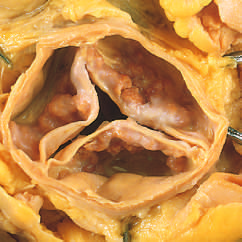how are the commissures stenosis?
Answer the question using a single word or phrase. Not fused 